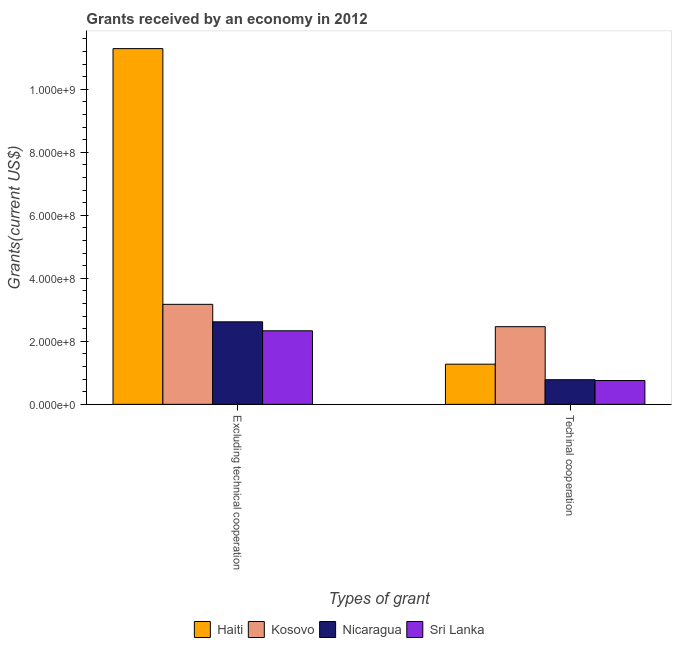How many different coloured bars are there?
Offer a terse response. 4. Are the number of bars per tick equal to the number of legend labels?
Your answer should be compact. Yes. What is the label of the 2nd group of bars from the left?
Offer a very short reply. Techinal cooperation. What is the amount of grants received(excluding technical cooperation) in Nicaragua?
Ensure brevity in your answer.  2.62e+08. Across all countries, what is the maximum amount of grants received(excluding technical cooperation)?
Ensure brevity in your answer.  1.13e+09. Across all countries, what is the minimum amount of grants received(including technical cooperation)?
Give a very brief answer. 7.56e+07. In which country was the amount of grants received(including technical cooperation) maximum?
Offer a terse response. Kosovo. In which country was the amount of grants received(excluding technical cooperation) minimum?
Your response must be concise. Sri Lanka. What is the total amount of grants received(including technical cooperation) in the graph?
Provide a succinct answer. 5.28e+08. What is the difference between the amount of grants received(excluding technical cooperation) in Nicaragua and that in Haiti?
Provide a short and direct response. -8.67e+08. What is the difference between the amount of grants received(excluding technical cooperation) in Kosovo and the amount of grants received(including technical cooperation) in Sri Lanka?
Offer a very short reply. 2.42e+08. What is the average amount of grants received(including technical cooperation) per country?
Keep it short and to the point. 1.32e+08. What is the difference between the amount of grants received(including technical cooperation) and amount of grants received(excluding technical cooperation) in Nicaragua?
Provide a succinct answer. -1.84e+08. What is the ratio of the amount of grants received(including technical cooperation) in Kosovo to that in Nicaragua?
Your response must be concise. 3.15. In how many countries, is the amount of grants received(excluding technical cooperation) greater than the average amount of grants received(excluding technical cooperation) taken over all countries?
Your answer should be very brief. 1. What does the 2nd bar from the left in Techinal cooperation represents?
Provide a short and direct response. Kosovo. What does the 4th bar from the right in Techinal cooperation represents?
Provide a short and direct response. Haiti. How many bars are there?
Your answer should be compact. 8. What is the difference between two consecutive major ticks on the Y-axis?
Your answer should be compact. 2.00e+08. Where does the legend appear in the graph?
Provide a short and direct response. Bottom center. How are the legend labels stacked?
Ensure brevity in your answer.  Horizontal. What is the title of the graph?
Ensure brevity in your answer.  Grants received by an economy in 2012. Does "Togo" appear as one of the legend labels in the graph?
Keep it short and to the point. No. What is the label or title of the X-axis?
Ensure brevity in your answer.  Types of grant. What is the label or title of the Y-axis?
Provide a short and direct response. Grants(current US$). What is the Grants(current US$) of Haiti in Excluding technical cooperation?
Keep it short and to the point. 1.13e+09. What is the Grants(current US$) of Kosovo in Excluding technical cooperation?
Your response must be concise. 3.17e+08. What is the Grants(current US$) in Nicaragua in Excluding technical cooperation?
Your response must be concise. 2.62e+08. What is the Grants(current US$) of Sri Lanka in Excluding technical cooperation?
Give a very brief answer. 2.33e+08. What is the Grants(current US$) of Haiti in Techinal cooperation?
Your response must be concise. 1.28e+08. What is the Grants(current US$) of Kosovo in Techinal cooperation?
Provide a short and direct response. 2.46e+08. What is the Grants(current US$) in Nicaragua in Techinal cooperation?
Your answer should be very brief. 7.82e+07. What is the Grants(current US$) of Sri Lanka in Techinal cooperation?
Make the answer very short. 7.56e+07. Across all Types of grant, what is the maximum Grants(current US$) of Haiti?
Keep it short and to the point. 1.13e+09. Across all Types of grant, what is the maximum Grants(current US$) in Kosovo?
Give a very brief answer. 3.17e+08. Across all Types of grant, what is the maximum Grants(current US$) in Nicaragua?
Ensure brevity in your answer.  2.62e+08. Across all Types of grant, what is the maximum Grants(current US$) of Sri Lanka?
Offer a very short reply. 2.33e+08. Across all Types of grant, what is the minimum Grants(current US$) of Haiti?
Ensure brevity in your answer.  1.28e+08. Across all Types of grant, what is the minimum Grants(current US$) of Kosovo?
Make the answer very short. 2.46e+08. Across all Types of grant, what is the minimum Grants(current US$) in Nicaragua?
Make the answer very short. 7.82e+07. Across all Types of grant, what is the minimum Grants(current US$) in Sri Lanka?
Offer a terse response. 7.56e+07. What is the total Grants(current US$) of Haiti in the graph?
Make the answer very short. 1.26e+09. What is the total Grants(current US$) of Kosovo in the graph?
Your response must be concise. 5.64e+08. What is the total Grants(current US$) of Nicaragua in the graph?
Make the answer very short. 3.40e+08. What is the total Grants(current US$) of Sri Lanka in the graph?
Make the answer very short. 3.09e+08. What is the difference between the Grants(current US$) in Haiti in Excluding technical cooperation and that in Techinal cooperation?
Offer a terse response. 1.00e+09. What is the difference between the Grants(current US$) in Kosovo in Excluding technical cooperation and that in Techinal cooperation?
Keep it short and to the point. 7.10e+07. What is the difference between the Grants(current US$) of Nicaragua in Excluding technical cooperation and that in Techinal cooperation?
Provide a succinct answer. 1.84e+08. What is the difference between the Grants(current US$) of Sri Lanka in Excluding technical cooperation and that in Techinal cooperation?
Offer a terse response. 1.58e+08. What is the difference between the Grants(current US$) of Haiti in Excluding technical cooperation and the Grants(current US$) of Kosovo in Techinal cooperation?
Offer a very short reply. 8.82e+08. What is the difference between the Grants(current US$) in Haiti in Excluding technical cooperation and the Grants(current US$) in Nicaragua in Techinal cooperation?
Offer a terse response. 1.05e+09. What is the difference between the Grants(current US$) of Haiti in Excluding technical cooperation and the Grants(current US$) of Sri Lanka in Techinal cooperation?
Your answer should be compact. 1.05e+09. What is the difference between the Grants(current US$) in Kosovo in Excluding technical cooperation and the Grants(current US$) in Nicaragua in Techinal cooperation?
Your answer should be very brief. 2.39e+08. What is the difference between the Grants(current US$) in Kosovo in Excluding technical cooperation and the Grants(current US$) in Sri Lanka in Techinal cooperation?
Your response must be concise. 2.42e+08. What is the difference between the Grants(current US$) of Nicaragua in Excluding technical cooperation and the Grants(current US$) of Sri Lanka in Techinal cooperation?
Offer a very short reply. 1.86e+08. What is the average Grants(current US$) of Haiti per Types of grant?
Keep it short and to the point. 6.28e+08. What is the average Grants(current US$) in Kosovo per Types of grant?
Make the answer very short. 2.82e+08. What is the average Grants(current US$) of Nicaragua per Types of grant?
Your response must be concise. 1.70e+08. What is the average Grants(current US$) of Sri Lanka per Types of grant?
Offer a very short reply. 1.55e+08. What is the difference between the Grants(current US$) in Haiti and Grants(current US$) in Kosovo in Excluding technical cooperation?
Provide a succinct answer. 8.12e+08. What is the difference between the Grants(current US$) of Haiti and Grants(current US$) of Nicaragua in Excluding technical cooperation?
Your answer should be compact. 8.67e+08. What is the difference between the Grants(current US$) in Haiti and Grants(current US$) in Sri Lanka in Excluding technical cooperation?
Your response must be concise. 8.96e+08. What is the difference between the Grants(current US$) in Kosovo and Grants(current US$) in Nicaragua in Excluding technical cooperation?
Provide a short and direct response. 5.55e+07. What is the difference between the Grants(current US$) in Kosovo and Grants(current US$) in Sri Lanka in Excluding technical cooperation?
Your answer should be compact. 8.40e+07. What is the difference between the Grants(current US$) of Nicaragua and Grants(current US$) of Sri Lanka in Excluding technical cooperation?
Your response must be concise. 2.84e+07. What is the difference between the Grants(current US$) of Haiti and Grants(current US$) of Kosovo in Techinal cooperation?
Your answer should be very brief. -1.19e+08. What is the difference between the Grants(current US$) of Haiti and Grants(current US$) of Nicaragua in Techinal cooperation?
Your response must be concise. 4.93e+07. What is the difference between the Grants(current US$) of Haiti and Grants(current US$) of Sri Lanka in Techinal cooperation?
Your answer should be compact. 5.19e+07. What is the difference between the Grants(current US$) in Kosovo and Grants(current US$) in Nicaragua in Techinal cooperation?
Ensure brevity in your answer.  1.68e+08. What is the difference between the Grants(current US$) in Kosovo and Grants(current US$) in Sri Lanka in Techinal cooperation?
Offer a very short reply. 1.71e+08. What is the difference between the Grants(current US$) in Nicaragua and Grants(current US$) in Sri Lanka in Techinal cooperation?
Keep it short and to the point. 2.65e+06. What is the ratio of the Grants(current US$) of Haiti in Excluding technical cooperation to that in Techinal cooperation?
Your answer should be very brief. 8.85. What is the ratio of the Grants(current US$) of Kosovo in Excluding technical cooperation to that in Techinal cooperation?
Offer a terse response. 1.29. What is the ratio of the Grants(current US$) in Nicaragua in Excluding technical cooperation to that in Techinal cooperation?
Your answer should be compact. 3.35. What is the ratio of the Grants(current US$) of Sri Lanka in Excluding technical cooperation to that in Techinal cooperation?
Make the answer very short. 3.09. What is the difference between the highest and the second highest Grants(current US$) of Haiti?
Keep it short and to the point. 1.00e+09. What is the difference between the highest and the second highest Grants(current US$) in Kosovo?
Make the answer very short. 7.10e+07. What is the difference between the highest and the second highest Grants(current US$) of Nicaragua?
Offer a terse response. 1.84e+08. What is the difference between the highest and the second highest Grants(current US$) in Sri Lanka?
Provide a succinct answer. 1.58e+08. What is the difference between the highest and the lowest Grants(current US$) of Haiti?
Ensure brevity in your answer.  1.00e+09. What is the difference between the highest and the lowest Grants(current US$) of Kosovo?
Your answer should be compact. 7.10e+07. What is the difference between the highest and the lowest Grants(current US$) in Nicaragua?
Your answer should be compact. 1.84e+08. What is the difference between the highest and the lowest Grants(current US$) in Sri Lanka?
Your answer should be very brief. 1.58e+08. 